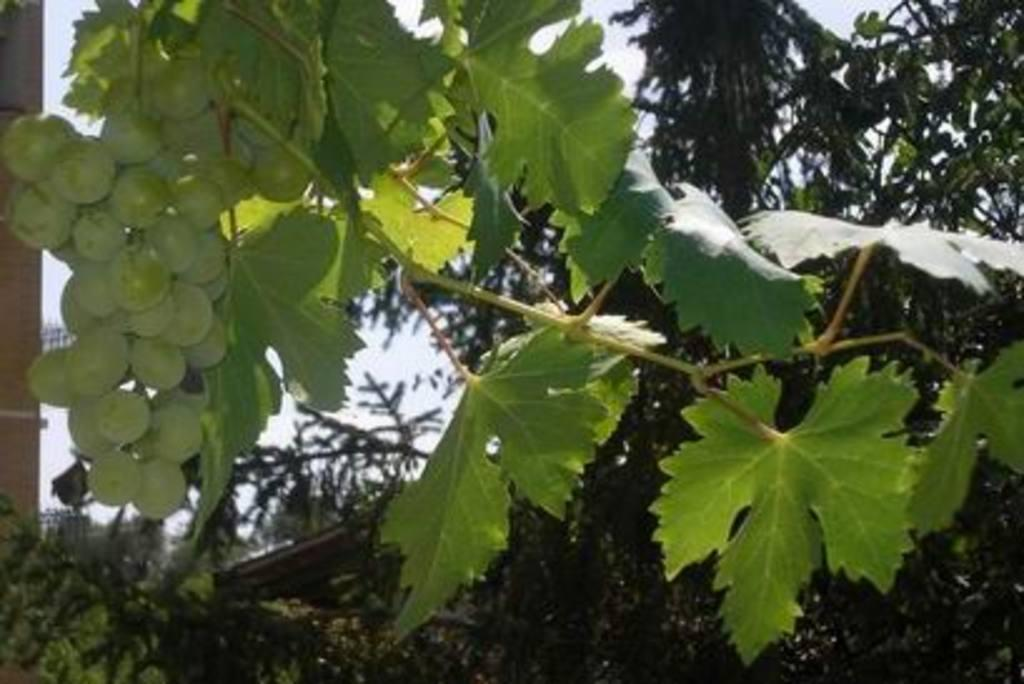What type of fruit can be seen on the left side of the image? There is a bunch of grapes on the left side of the image. What can be seen in the background of the image? There are trees and the sky visible in the background of the image. How many frogs are sitting on the patch in the image? There are no frogs or patches present in the image. 